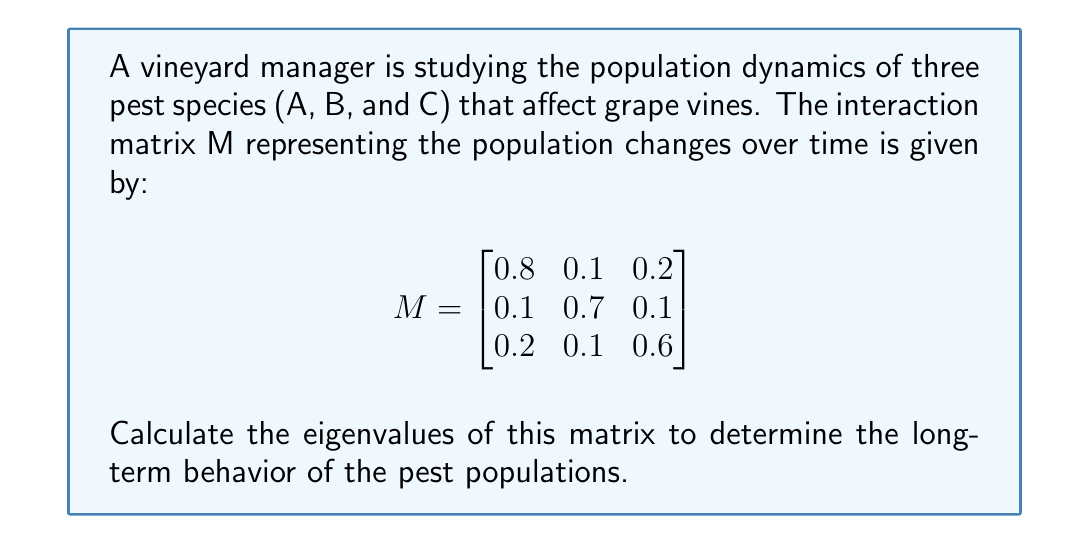Teach me how to tackle this problem. To find the eigenvalues of matrix M, we need to solve the characteristic equation:

1) First, we set up the equation $det(M - \lambda I) = 0$, where $\lambda$ represents the eigenvalues and I is the 3x3 identity matrix:

   $$det\begin{pmatrix}
   0.8-\lambda & 0.1 & 0.2 \\
   0.1 & 0.7-\lambda & 0.1 \\
   0.2 & 0.1 & 0.6-\lambda
   \end{pmatrix} = 0$$

2) Expanding the determinant:
   
   $(0.8-\lambda)[(0.7-\lambda)(0.6-\lambda)-0.01] - 0.1[0.1(0.6-\lambda)-0.02] + 0.2[0.1(0.7-\lambda)-0.01] = 0$

3) Simplifying:
   
   $(0.8-\lambda)(0.42-1.3\lambda+\lambda^2) - 0.1(0.06-0.1\lambda) + 0.2(0.07-0.1\lambda) = 0$

4) Expanding further:
   
   $0.336 - 1.04\lambda + 0.8\lambda^2 - 0.42\lambda + 1.3\lambda^2 - \lambda^3 - 0.006 + 0.01\lambda + 0.014 - 0.02\lambda = 0$

5) Collecting like terms:
   
   $-\lambda^3 + 2.1\lambda^2 - 1.47\lambda + 0.344 = 0$

6) This is a cubic equation. We can solve it using the cubic formula or a computer algebra system. The solutions are the eigenvalues:

   $\lambda_1 \approx 1.0$
   $\lambda_2 \approx 0.7$
   $\lambda_3 \approx 0.4$

These eigenvalues provide information about the long-term behavior of the pest populations. The largest eigenvalue (1.0) suggests that one pest population may grow over time, while the others (0.7 and 0.4) indicate declining populations.
Answer: $\lambda_1 \approx 1.0$, $\lambda_2 \approx 0.7$, $\lambda_3 \approx 0.4$ 